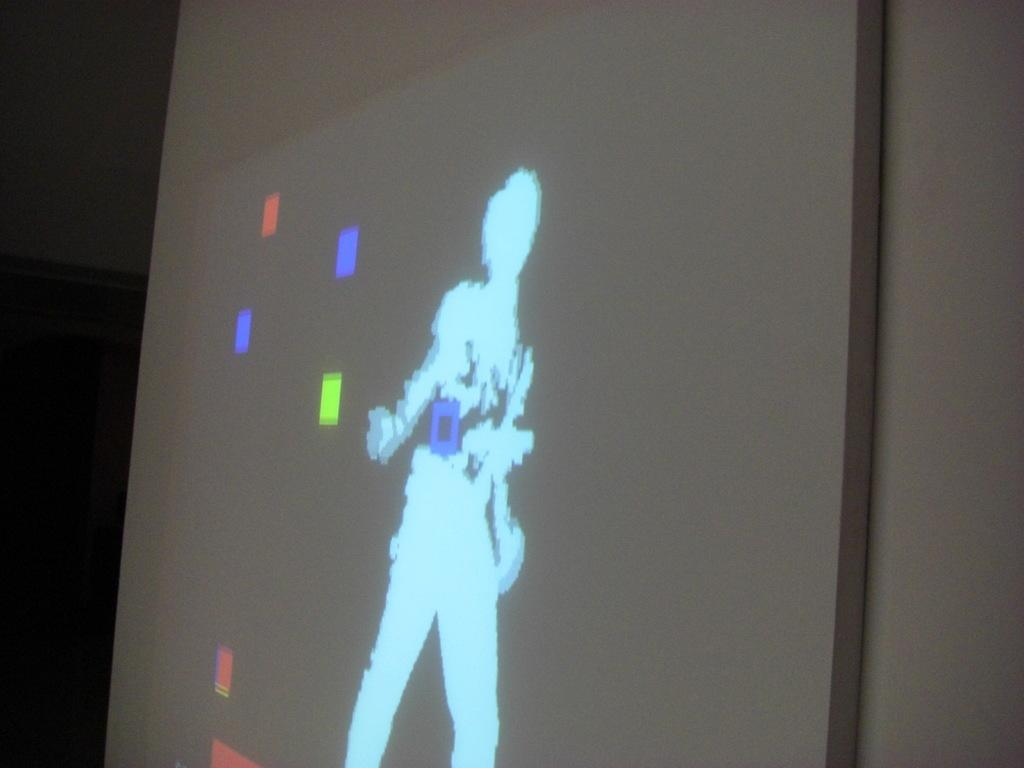What is partially visible in the image? There is a part of the screen visible in the image. What can be observed on the screen? The screen has colors on it, and there is a person's image on the screen. What type of wine is being served in the image? There is no wine present in the image; it features a part of a screen with colors and a person's image. Is there a tiger visible in the image? No, there is no tiger present in the image. 